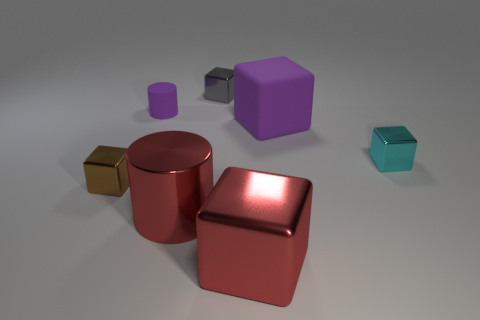There is a large matte object that is the same shape as the gray shiny object; what is its color?
Give a very brief answer. Purple. Is there any other thing that has the same shape as the small gray metallic object?
Keep it short and to the point. Yes. Is the shape of the tiny gray thing the same as the purple rubber thing that is on the right side of the tiny gray cube?
Give a very brief answer. Yes. What number of other things are there of the same material as the purple cube
Your answer should be compact. 1. Does the metal cylinder have the same color as the large block in front of the cyan block?
Keep it short and to the point. Yes. There is a big cube that is in front of the brown cube; what is its material?
Offer a terse response. Metal. Are there any large objects that have the same color as the metallic cylinder?
Provide a succinct answer. Yes. The matte object that is the same size as the cyan metallic block is what color?
Keep it short and to the point. Purple. What number of small things are purple cubes or metallic things?
Ensure brevity in your answer.  3. Is the number of big objects that are behind the matte cylinder the same as the number of tiny brown blocks that are left of the brown metallic cube?
Your response must be concise. Yes. 